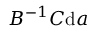Convert formula to latex. <formula><loc_0><loc_0><loc_500><loc_500>B ^ { - 1 } C { d } a</formula> 